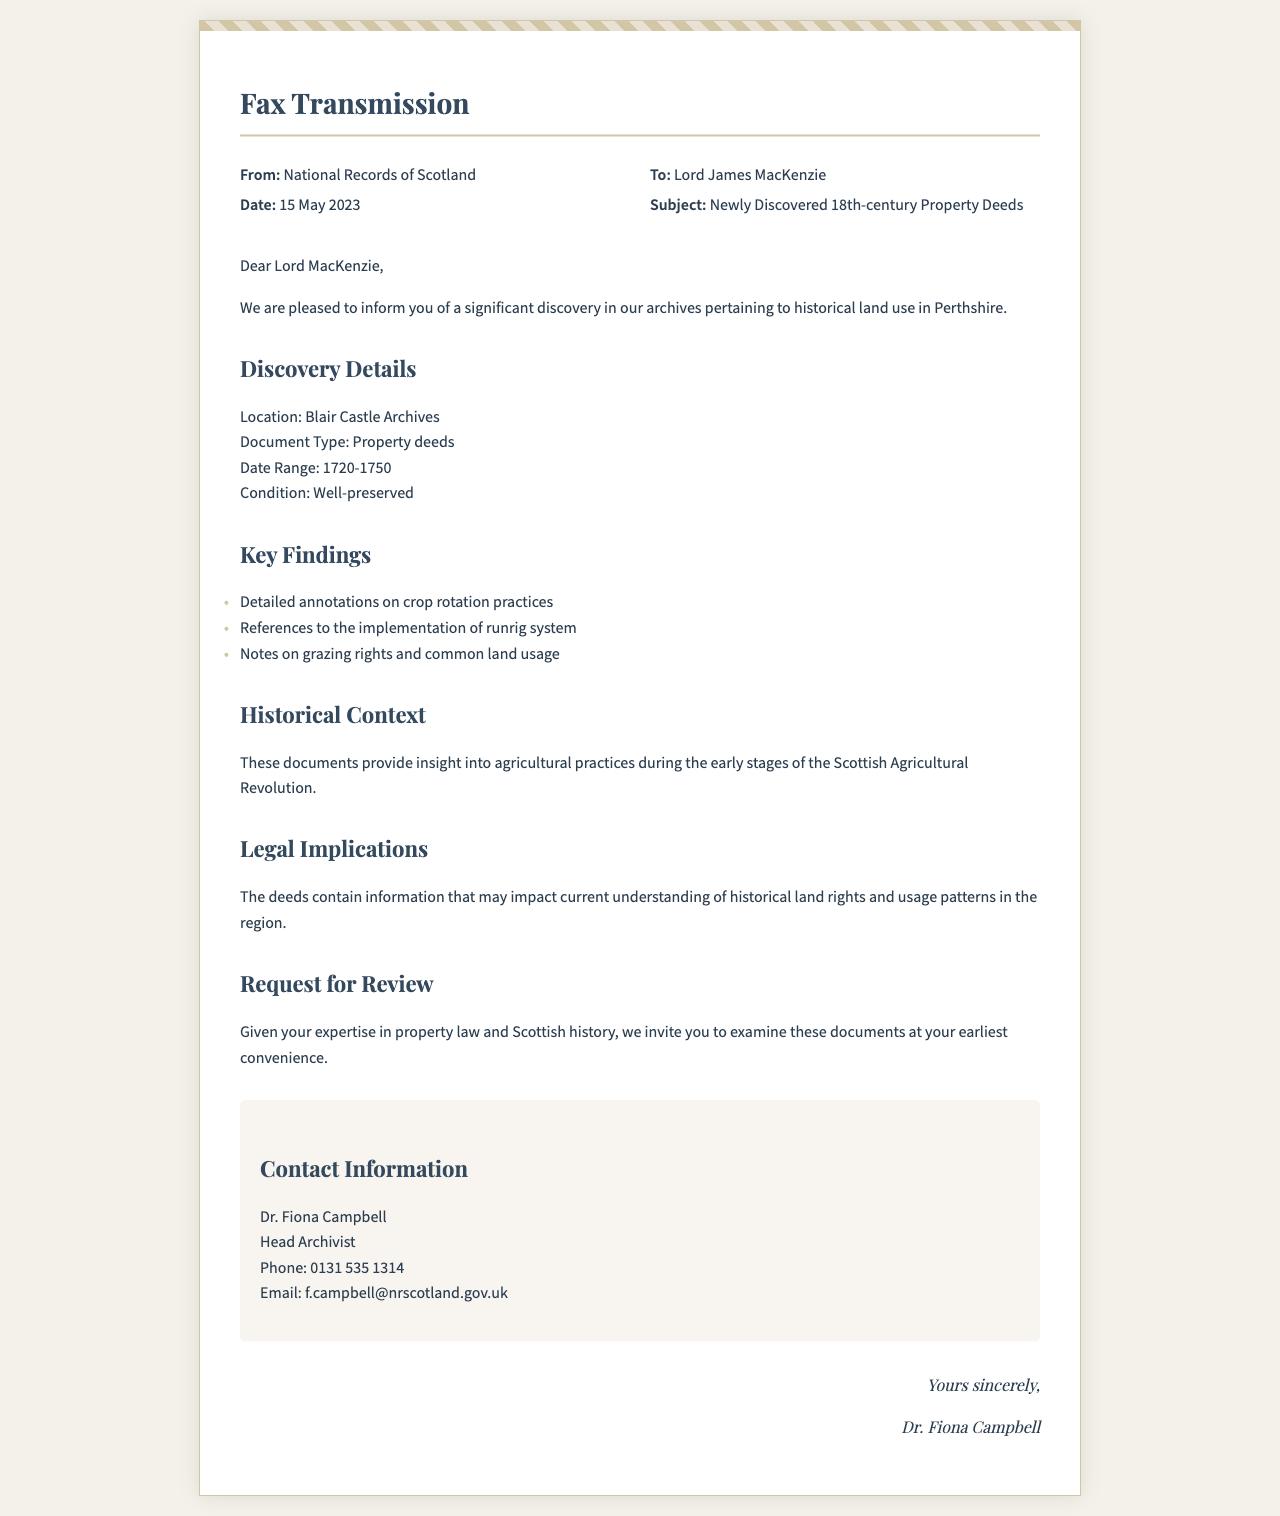What is the date of the fax? The date of the fax is specified in the header information of the document.
Answer: 15 May 2023 Who is the sender of the fax? The sender's name is mentioned at the top of the document.
Answer: National Records of Scotland What is the main subject of the fax? The subject is indicated next to the recipient's name in the header.
Answer: Newly Discovered 18th-century Property Deeds What is the location of the discovery? The location is provided in the discovery details section.
Answer: Blair Castle Archives What year range do the property deeds cover? The date range is outlined in the discovery details.
Answer: 1720-1750 How many key findings are listed in the document? The number of findings can be determined by counting the list items in the "Key Findings" section.
Answer: Three What agricultural practice is referenced in the documents? The document lists specific practices related to historical land use.
Answer: Crop rotation What type of legal implications does the document mention? The document discusses how the findings may affect legal understanding.
Answer: Historical land rights Who is the contact person for further inquiries? The contact person's name appears in the contact information section.
Answer: Dr. Fiona Campbell 